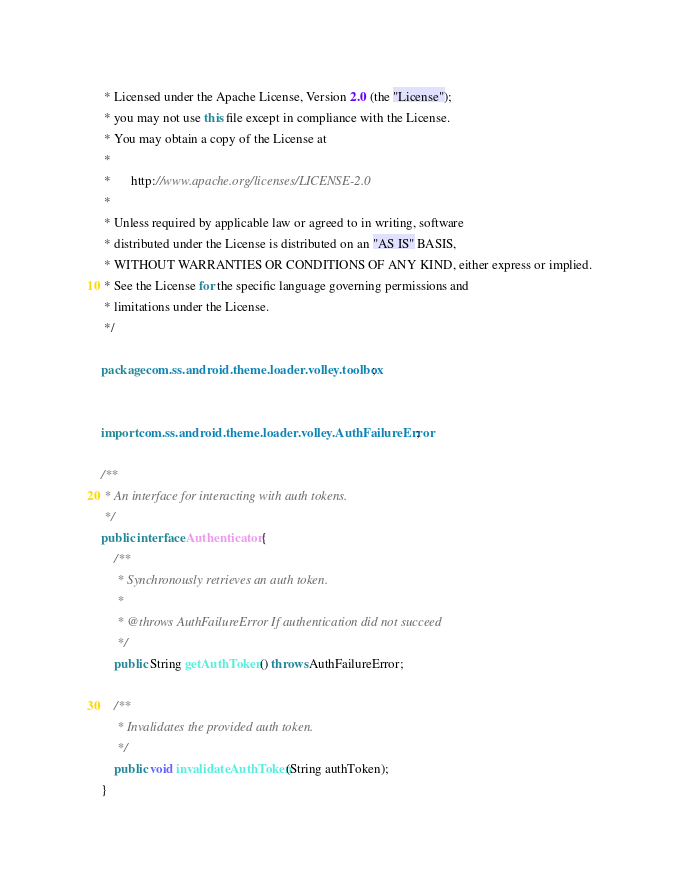<code> <loc_0><loc_0><loc_500><loc_500><_Java_> * Licensed under the Apache License, Version 2.0 (the "License");
 * you may not use this file except in compliance with the License.
 * You may obtain a copy of the License at
 *
 *      http://www.apache.org/licenses/LICENSE-2.0
 *
 * Unless required by applicable law or agreed to in writing, software
 * distributed under the License is distributed on an "AS IS" BASIS,
 * WITHOUT WARRANTIES OR CONDITIONS OF ANY KIND, either express or implied.
 * See the License for the specific language governing permissions and
 * limitations under the License.
 */

package com.ss.android.theme.loader.volley.toolbox;


import com.ss.android.theme.loader.volley.AuthFailureError;

/**
 * An interface for interacting with auth tokens.
 */
public interface Authenticator {
    /**
     * Synchronously retrieves an auth token.
     *
     * @throws AuthFailureError If authentication did not succeed
     */
    public String getAuthToken() throws AuthFailureError;

    /**
     * Invalidates the provided auth token.
     */
    public void invalidateAuthToken(String authToken);
}
</code> 